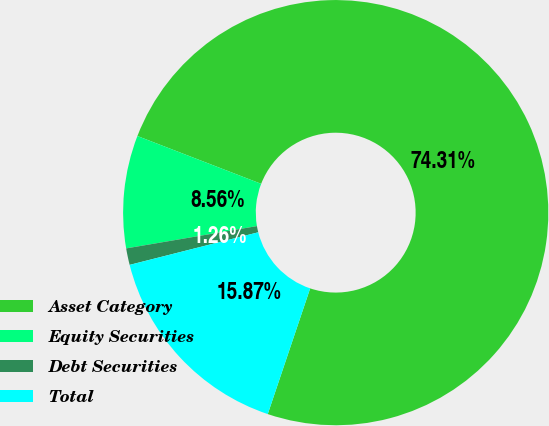<chart> <loc_0><loc_0><loc_500><loc_500><pie_chart><fcel>Asset Category<fcel>Equity Securities<fcel>Debt Securities<fcel>Total<nl><fcel>74.31%<fcel>8.56%<fcel>1.26%<fcel>15.87%<nl></chart> 